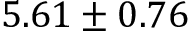<formula> <loc_0><loc_0><loc_500><loc_500>5 . 6 1 \pm 0 . 7 6</formula> 